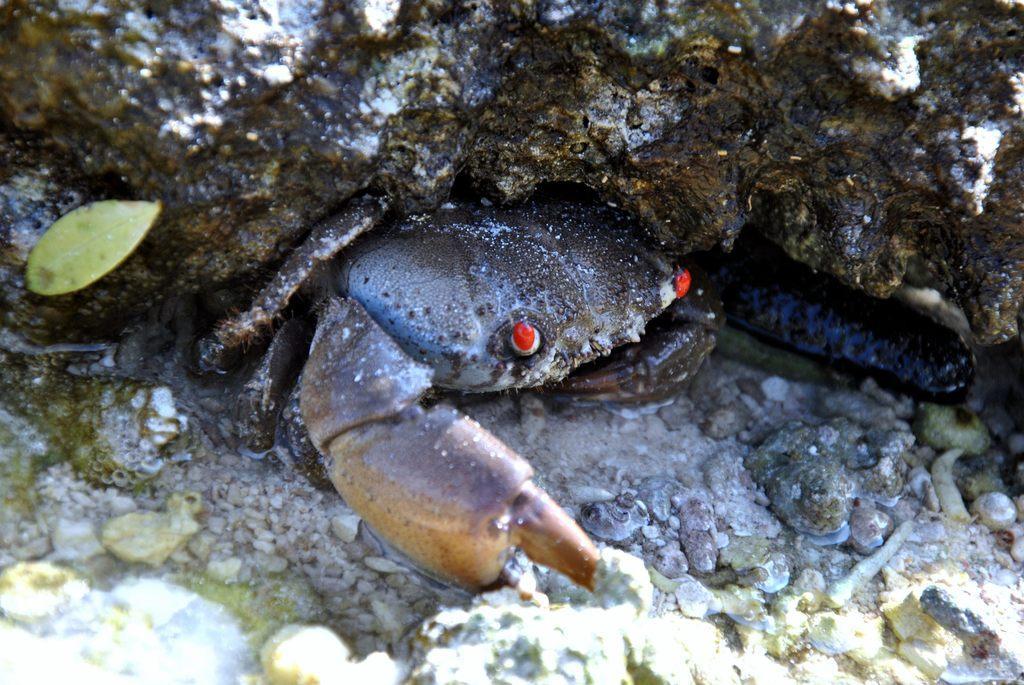In one or two sentences, can you explain what this image depicts? In this image I can see a crab in the water, stones, leaf and rock. This image is taken may be during a day. 